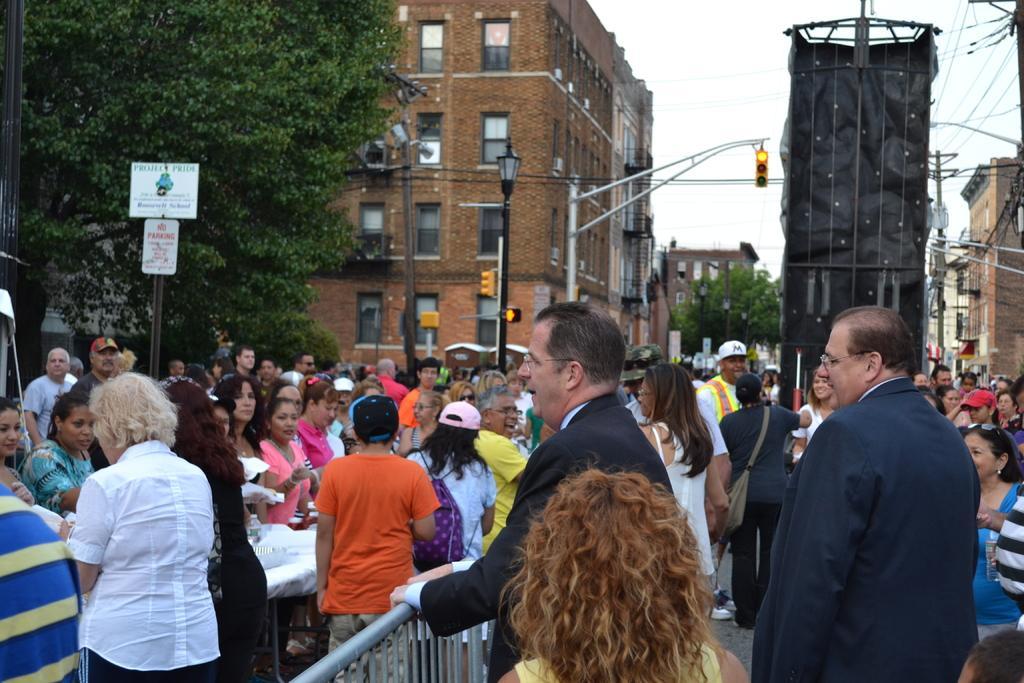Please provide a concise description of this image. In this image we can see many people standing on the road. We can also see the buildings, trees, light poles and also wires. We can also see the signboard, traffic signal poles and also the fence. On the right there is a black color object. Sky is also visible. 